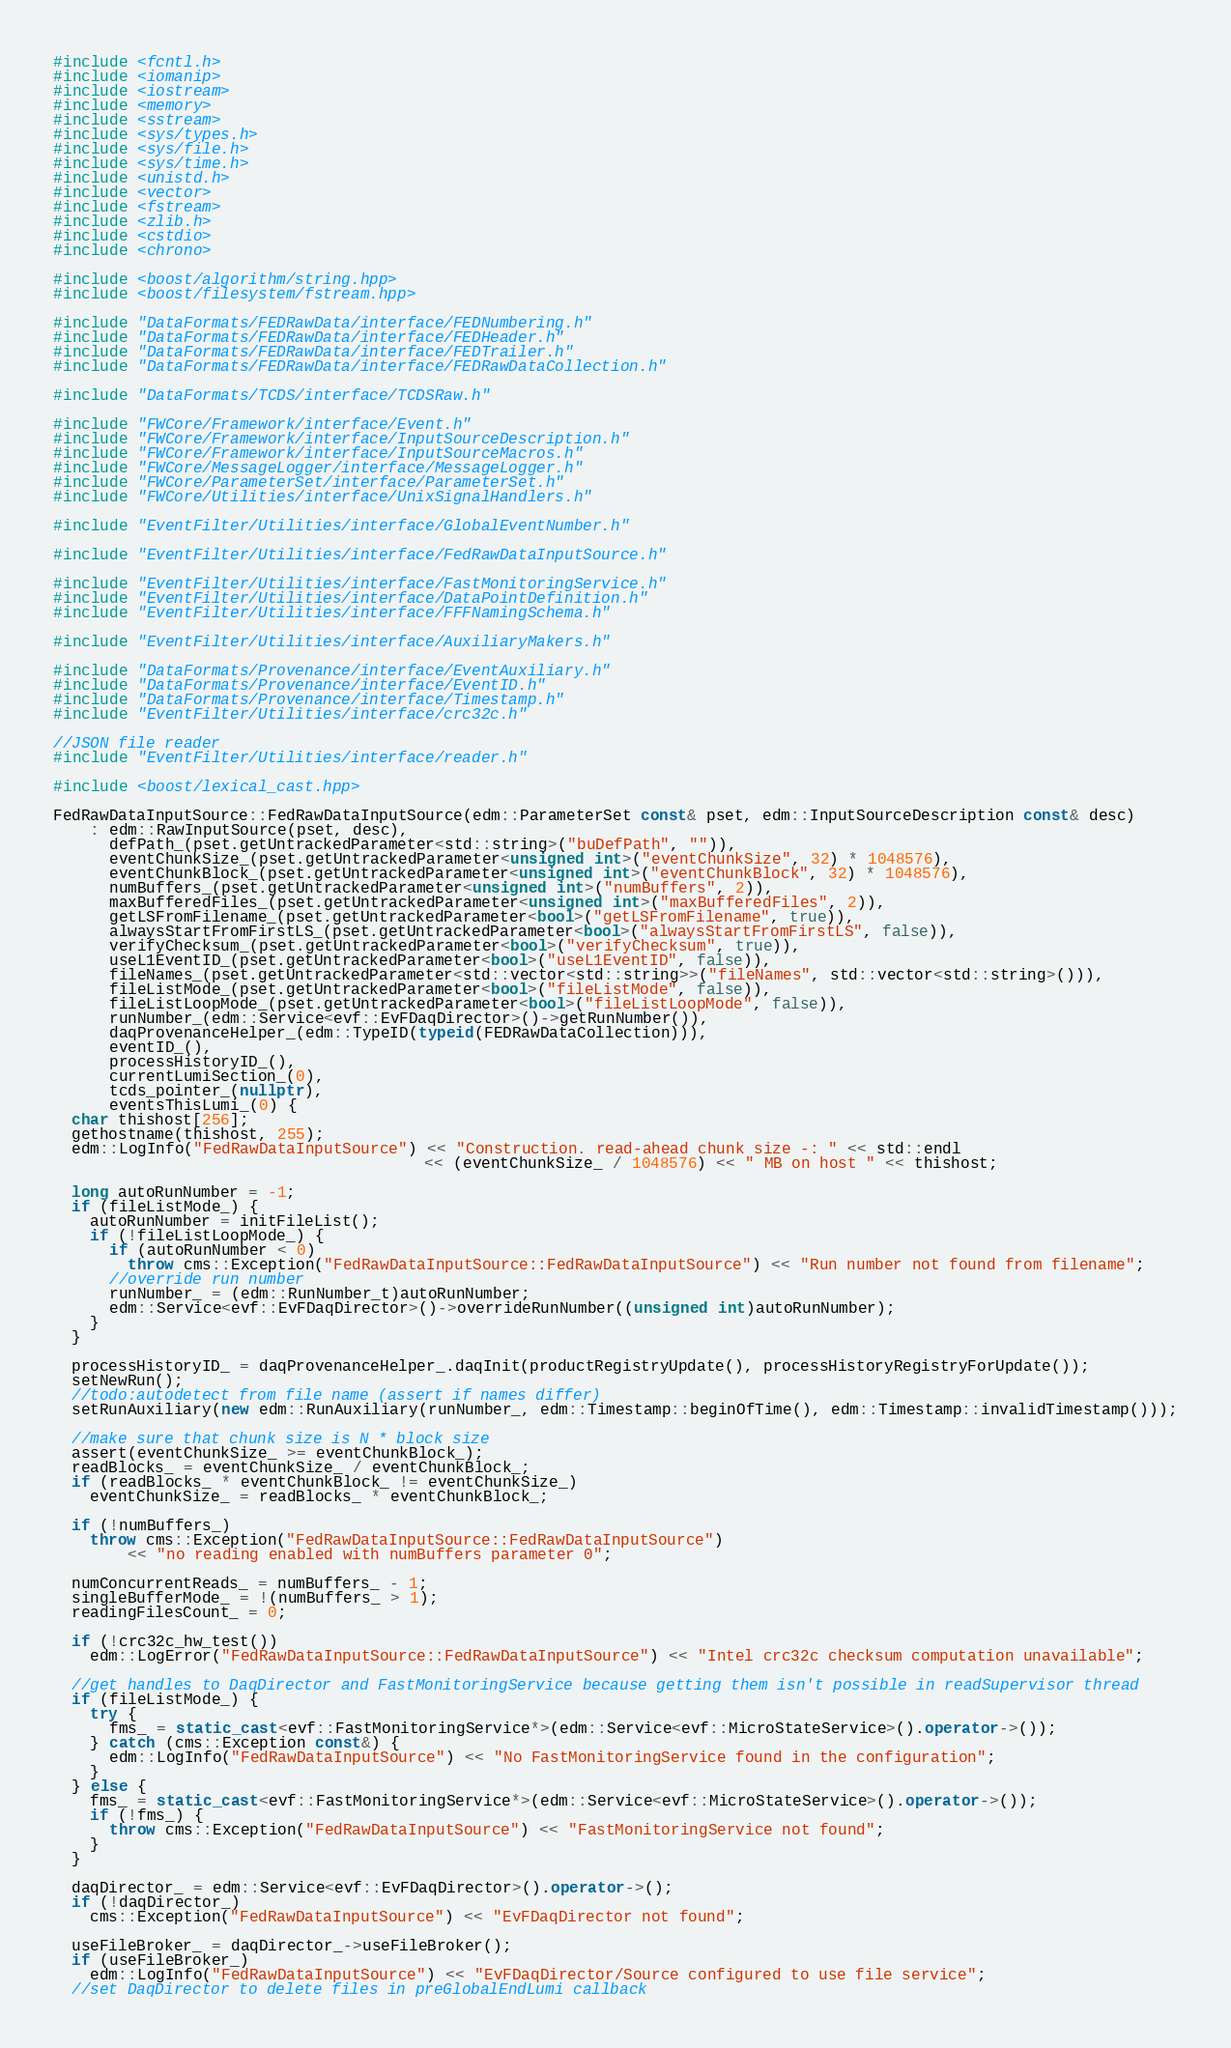Convert code to text. <code><loc_0><loc_0><loc_500><loc_500><_C++_>#include <fcntl.h>
#include <iomanip>
#include <iostream>
#include <memory>
#include <sstream>
#include <sys/types.h>
#include <sys/file.h>
#include <sys/time.h>
#include <unistd.h>
#include <vector>
#include <fstream>
#include <zlib.h>
#include <cstdio>
#include <chrono>

#include <boost/algorithm/string.hpp>
#include <boost/filesystem/fstream.hpp>

#include "DataFormats/FEDRawData/interface/FEDNumbering.h"
#include "DataFormats/FEDRawData/interface/FEDHeader.h"
#include "DataFormats/FEDRawData/interface/FEDTrailer.h"
#include "DataFormats/FEDRawData/interface/FEDRawDataCollection.h"

#include "DataFormats/TCDS/interface/TCDSRaw.h"

#include "FWCore/Framework/interface/Event.h"
#include "FWCore/Framework/interface/InputSourceDescription.h"
#include "FWCore/Framework/interface/InputSourceMacros.h"
#include "FWCore/MessageLogger/interface/MessageLogger.h"
#include "FWCore/ParameterSet/interface/ParameterSet.h"
#include "FWCore/Utilities/interface/UnixSignalHandlers.h"

#include "EventFilter/Utilities/interface/GlobalEventNumber.h"

#include "EventFilter/Utilities/interface/FedRawDataInputSource.h"

#include "EventFilter/Utilities/interface/FastMonitoringService.h"
#include "EventFilter/Utilities/interface/DataPointDefinition.h"
#include "EventFilter/Utilities/interface/FFFNamingSchema.h"

#include "EventFilter/Utilities/interface/AuxiliaryMakers.h"

#include "DataFormats/Provenance/interface/EventAuxiliary.h"
#include "DataFormats/Provenance/interface/EventID.h"
#include "DataFormats/Provenance/interface/Timestamp.h"
#include "EventFilter/Utilities/interface/crc32c.h"

//JSON file reader
#include "EventFilter/Utilities/interface/reader.h"

#include <boost/lexical_cast.hpp>

FedRawDataInputSource::FedRawDataInputSource(edm::ParameterSet const& pset, edm::InputSourceDescription const& desc)
    : edm::RawInputSource(pset, desc),
      defPath_(pset.getUntrackedParameter<std::string>("buDefPath", "")),
      eventChunkSize_(pset.getUntrackedParameter<unsigned int>("eventChunkSize", 32) * 1048576),
      eventChunkBlock_(pset.getUntrackedParameter<unsigned int>("eventChunkBlock", 32) * 1048576),
      numBuffers_(pset.getUntrackedParameter<unsigned int>("numBuffers", 2)),
      maxBufferedFiles_(pset.getUntrackedParameter<unsigned int>("maxBufferedFiles", 2)),
      getLSFromFilename_(pset.getUntrackedParameter<bool>("getLSFromFilename", true)),
      alwaysStartFromFirstLS_(pset.getUntrackedParameter<bool>("alwaysStartFromFirstLS", false)),
      verifyChecksum_(pset.getUntrackedParameter<bool>("verifyChecksum", true)),
      useL1EventID_(pset.getUntrackedParameter<bool>("useL1EventID", false)),
      fileNames_(pset.getUntrackedParameter<std::vector<std::string>>("fileNames", std::vector<std::string>())),
      fileListMode_(pset.getUntrackedParameter<bool>("fileListMode", false)),
      fileListLoopMode_(pset.getUntrackedParameter<bool>("fileListLoopMode", false)),
      runNumber_(edm::Service<evf::EvFDaqDirector>()->getRunNumber()),
      daqProvenanceHelper_(edm::TypeID(typeid(FEDRawDataCollection))),
      eventID_(),
      processHistoryID_(),
      currentLumiSection_(0),
      tcds_pointer_(nullptr),
      eventsThisLumi_(0) {
  char thishost[256];
  gethostname(thishost, 255);
  edm::LogInfo("FedRawDataInputSource") << "Construction. read-ahead chunk size -: " << std::endl
                                        << (eventChunkSize_ / 1048576) << " MB on host " << thishost;

  long autoRunNumber = -1;
  if (fileListMode_) {
    autoRunNumber = initFileList();
    if (!fileListLoopMode_) {
      if (autoRunNumber < 0)
        throw cms::Exception("FedRawDataInputSource::FedRawDataInputSource") << "Run number not found from filename";
      //override run number
      runNumber_ = (edm::RunNumber_t)autoRunNumber;
      edm::Service<evf::EvFDaqDirector>()->overrideRunNumber((unsigned int)autoRunNumber);
    }
  }

  processHistoryID_ = daqProvenanceHelper_.daqInit(productRegistryUpdate(), processHistoryRegistryForUpdate());
  setNewRun();
  //todo:autodetect from file name (assert if names differ)
  setRunAuxiliary(new edm::RunAuxiliary(runNumber_, edm::Timestamp::beginOfTime(), edm::Timestamp::invalidTimestamp()));

  //make sure that chunk size is N * block size
  assert(eventChunkSize_ >= eventChunkBlock_);
  readBlocks_ = eventChunkSize_ / eventChunkBlock_;
  if (readBlocks_ * eventChunkBlock_ != eventChunkSize_)
    eventChunkSize_ = readBlocks_ * eventChunkBlock_;

  if (!numBuffers_)
    throw cms::Exception("FedRawDataInputSource::FedRawDataInputSource")
        << "no reading enabled with numBuffers parameter 0";

  numConcurrentReads_ = numBuffers_ - 1;
  singleBufferMode_ = !(numBuffers_ > 1);
  readingFilesCount_ = 0;

  if (!crc32c_hw_test())
    edm::LogError("FedRawDataInputSource::FedRawDataInputSource") << "Intel crc32c checksum computation unavailable";

  //get handles to DaqDirector and FastMonitoringService because getting them isn't possible in readSupervisor thread
  if (fileListMode_) {
    try {
      fms_ = static_cast<evf::FastMonitoringService*>(edm::Service<evf::MicroStateService>().operator->());
    } catch (cms::Exception const&) {
      edm::LogInfo("FedRawDataInputSource") << "No FastMonitoringService found in the configuration";
    }
  } else {
    fms_ = static_cast<evf::FastMonitoringService*>(edm::Service<evf::MicroStateService>().operator->());
    if (!fms_) {
      throw cms::Exception("FedRawDataInputSource") << "FastMonitoringService not found";
    }
  }

  daqDirector_ = edm::Service<evf::EvFDaqDirector>().operator->();
  if (!daqDirector_)
    cms::Exception("FedRawDataInputSource") << "EvFDaqDirector not found";

  useFileBroker_ = daqDirector_->useFileBroker();
  if (useFileBroker_)
    edm::LogInfo("FedRawDataInputSource") << "EvFDaqDirector/Source configured to use file service";
  //set DaqDirector to delete files in preGlobalEndLumi callback</code> 